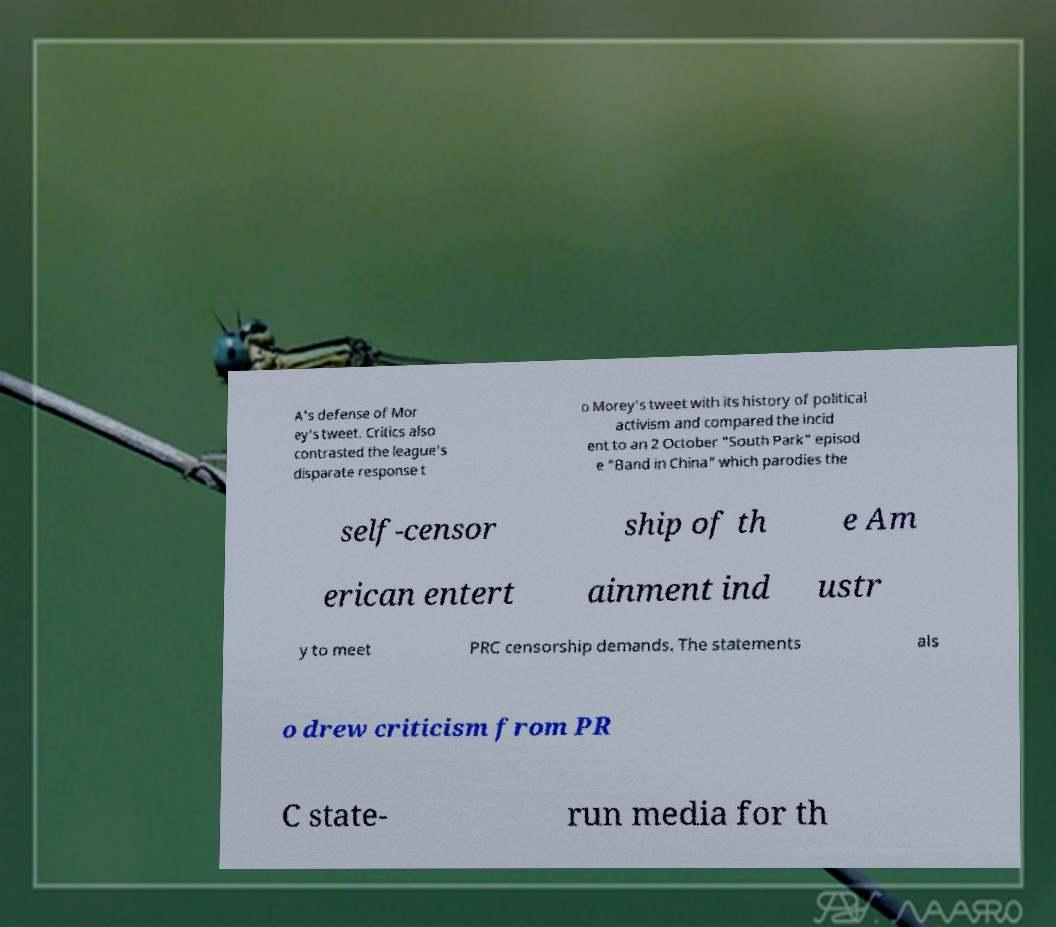Can you accurately transcribe the text from the provided image for me? A's defense of Mor ey's tweet. Critics also contrasted the league's disparate response t o Morey's tweet with its history of political activism and compared the incid ent to an 2 October "South Park" episod e "Band in China" which parodies the self-censor ship of th e Am erican entert ainment ind ustr y to meet PRC censorship demands. The statements als o drew criticism from PR C state- run media for th 